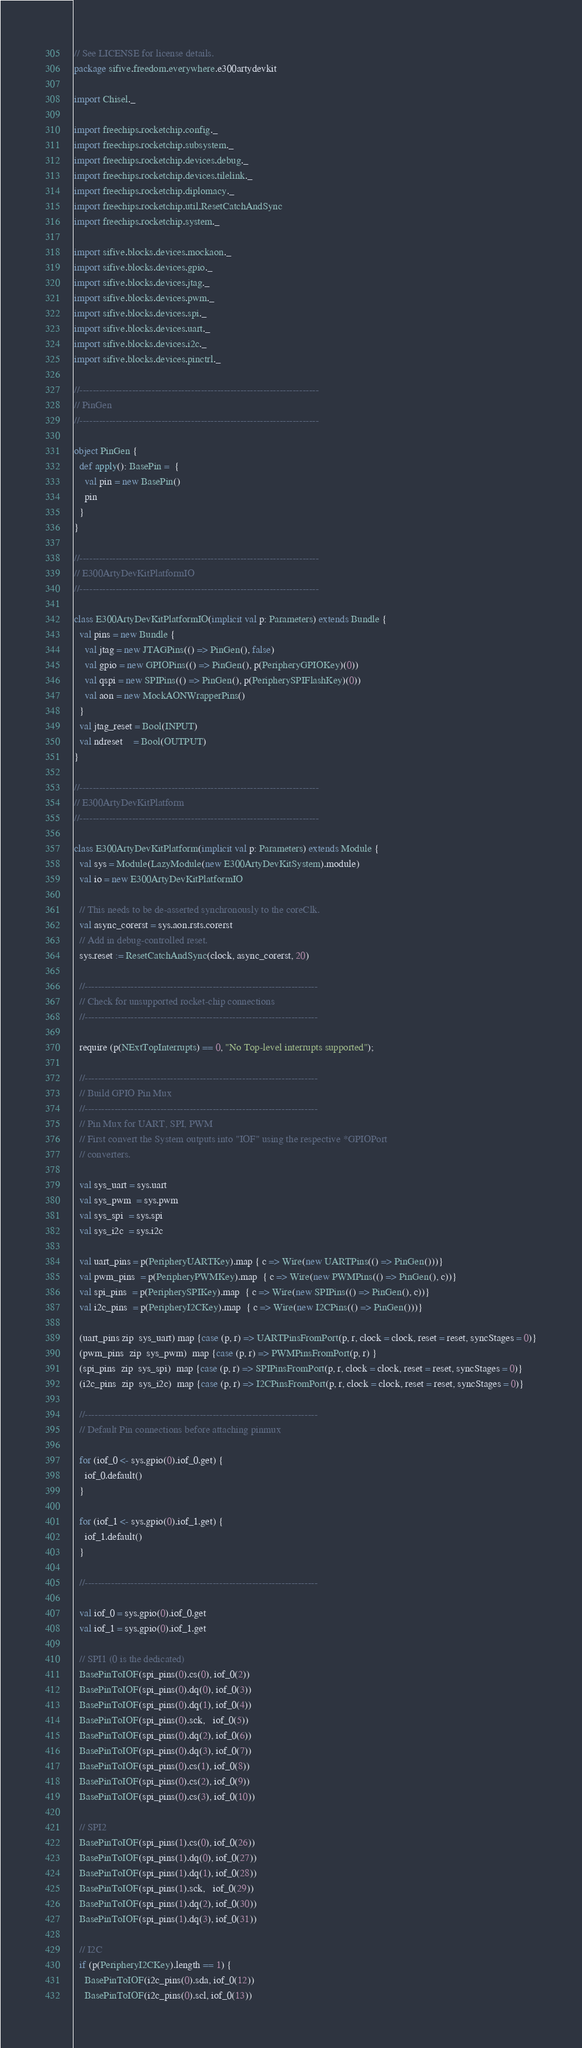<code> <loc_0><loc_0><loc_500><loc_500><_Scala_>// See LICENSE for license details.
package sifive.freedom.everywhere.e300artydevkit

import Chisel._

import freechips.rocketchip.config._
import freechips.rocketchip.subsystem._
import freechips.rocketchip.devices.debug._
import freechips.rocketchip.devices.tilelink._
import freechips.rocketchip.diplomacy._
import freechips.rocketchip.util.ResetCatchAndSync
import freechips.rocketchip.system._

import sifive.blocks.devices.mockaon._
import sifive.blocks.devices.gpio._
import sifive.blocks.devices.jtag._
import sifive.blocks.devices.pwm._
import sifive.blocks.devices.spi._
import sifive.blocks.devices.uart._
import sifive.blocks.devices.i2c._
import sifive.blocks.devices.pinctrl._

//-------------------------------------------------------------------------
// PinGen
//-------------------------------------------------------------------------

object PinGen {
  def apply(): BasePin =  {
    val pin = new BasePin()
    pin
  }
}

//-------------------------------------------------------------------------
// E300ArtyDevKitPlatformIO
//-------------------------------------------------------------------------

class E300ArtyDevKitPlatformIO(implicit val p: Parameters) extends Bundle {
  val pins = new Bundle {
    val jtag = new JTAGPins(() => PinGen(), false)
    val gpio = new GPIOPins(() => PinGen(), p(PeripheryGPIOKey)(0))
    val qspi = new SPIPins(() => PinGen(), p(PeripherySPIFlashKey)(0))
    val aon = new MockAONWrapperPins()
  }
  val jtag_reset = Bool(INPUT)
  val ndreset    = Bool(OUTPUT)
}

//-------------------------------------------------------------------------
// E300ArtyDevKitPlatform
//-------------------------------------------------------------------------

class E300ArtyDevKitPlatform(implicit val p: Parameters) extends Module {
  val sys = Module(LazyModule(new E300ArtyDevKitSystem).module)
  val io = new E300ArtyDevKitPlatformIO

  // This needs to be de-asserted synchronously to the coreClk.
  val async_corerst = sys.aon.rsts.corerst
  // Add in debug-controlled reset.
  sys.reset := ResetCatchAndSync(clock, async_corerst, 20)

  //-----------------------------------------------------------------------
  // Check for unsupported rocket-chip connections
  //-----------------------------------------------------------------------

  require (p(NExtTopInterrupts) == 0, "No Top-level interrupts supported");

  //-----------------------------------------------------------------------
  // Build GPIO Pin Mux
  //-----------------------------------------------------------------------
  // Pin Mux for UART, SPI, PWM
  // First convert the System outputs into "IOF" using the respective *GPIOPort
  // converters.

  val sys_uart = sys.uart
  val sys_pwm  = sys.pwm
  val sys_spi  = sys.spi
  val sys_i2c  = sys.i2c

  val uart_pins = p(PeripheryUARTKey).map { c => Wire(new UARTPins(() => PinGen()))}
  val pwm_pins  = p(PeripheryPWMKey).map  { c => Wire(new PWMPins(() => PinGen(), c))}
  val spi_pins  = p(PeripherySPIKey).map  { c => Wire(new SPIPins(() => PinGen(), c))}
  val i2c_pins  = p(PeripheryI2CKey).map  { c => Wire(new I2CPins(() => PinGen()))}

  (uart_pins zip  sys_uart) map {case (p, r) => UARTPinsFromPort(p, r, clock = clock, reset = reset, syncStages = 0)}
  (pwm_pins  zip  sys_pwm)  map {case (p, r) => PWMPinsFromPort(p, r) }
  (spi_pins  zip  sys_spi)  map {case (p, r) => SPIPinsFromPort(p, r, clock = clock, reset = reset, syncStages = 0)}
  (i2c_pins  zip  sys_i2c)  map {case (p, r) => I2CPinsFromPort(p, r, clock = clock, reset = reset, syncStages = 0)}

  //-----------------------------------------------------------------------
  // Default Pin connections before attaching pinmux

  for (iof_0 <- sys.gpio(0).iof_0.get) {
    iof_0.default()
  }

  for (iof_1 <- sys.gpio(0).iof_1.get) {
    iof_1.default()
  }

  //-----------------------------------------------------------------------

  val iof_0 = sys.gpio(0).iof_0.get
  val iof_1 = sys.gpio(0).iof_1.get

  // SPI1 (0 is the dedicated)
  BasePinToIOF(spi_pins(0).cs(0), iof_0(2))
  BasePinToIOF(spi_pins(0).dq(0), iof_0(3))
  BasePinToIOF(spi_pins(0).dq(1), iof_0(4))
  BasePinToIOF(spi_pins(0).sck,   iof_0(5))
  BasePinToIOF(spi_pins(0).dq(2), iof_0(6))
  BasePinToIOF(spi_pins(0).dq(3), iof_0(7))
  BasePinToIOF(spi_pins(0).cs(1), iof_0(8))
  BasePinToIOF(spi_pins(0).cs(2), iof_0(9))
  BasePinToIOF(spi_pins(0).cs(3), iof_0(10))

  // SPI2
  BasePinToIOF(spi_pins(1).cs(0), iof_0(26))
  BasePinToIOF(spi_pins(1).dq(0), iof_0(27))
  BasePinToIOF(spi_pins(1).dq(1), iof_0(28))
  BasePinToIOF(spi_pins(1).sck,   iof_0(29))
  BasePinToIOF(spi_pins(1).dq(2), iof_0(30))
  BasePinToIOF(spi_pins(1).dq(3), iof_0(31))

  // I2C
  if (p(PeripheryI2CKey).length == 1) {
    BasePinToIOF(i2c_pins(0).sda, iof_0(12))
    BasePinToIOF(i2c_pins(0).scl, iof_0(13))</code> 